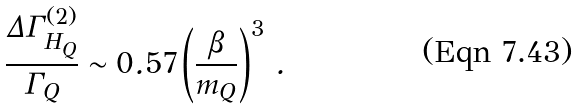<formula> <loc_0><loc_0><loc_500><loc_500>\frac { \Delta \Gamma _ { H _ { Q } } ^ { ( 2 ) } } { \Gamma _ { Q } } \sim 0 . 5 7 \left ( \frac { \beta } { m _ { Q } } \right ) ^ { 3 } \, .</formula> 